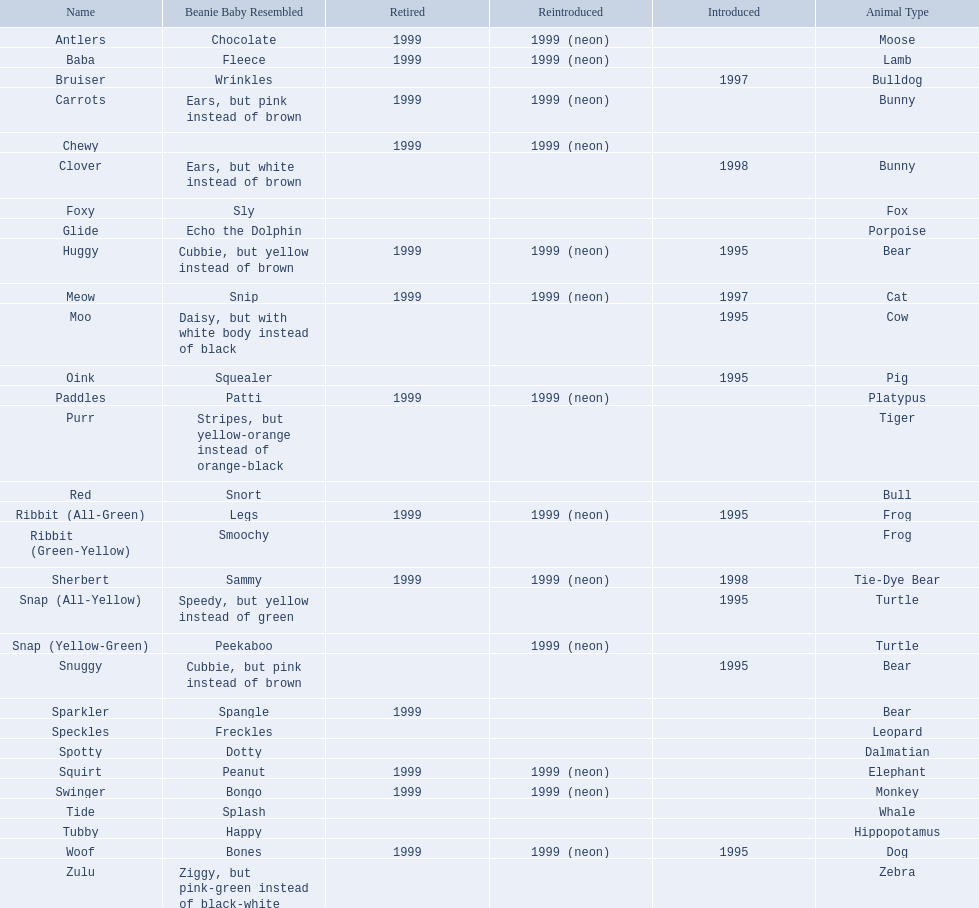What are all the different names of the pillow pals? Antlers, Baba, Bruiser, Carrots, Chewy, Clover, Foxy, Glide, Huggy, Meow, Moo, Oink, Paddles, Purr, Red, Ribbit (All-Green), Ribbit (Green-Yellow), Sherbert, Snap (All-Yellow), Snap (Yellow-Green), Snuggy, Sparkler, Speckles, Spotty, Squirt, Swinger, Tide, Tubby, Woof, Zulu. Which of these are a dalmatian? Spotty. Can you give me this table as a dict? {'header': ['Name', 'Beanie Baby Resembled', 'Retired', 'Reintroduced', 'Introduced', 'Animal Type'], 'rows': [['Antlers', 'Chocolate', '1999', '1999 (neon)', '', 'Moose'], ['Baba', 'Fleece', '1999', '1999 (neon)', '', 'Lamb'], ['Bruiser', 'Wrinkles', '', '', '1997', 'Bulldog'], ['Carrots', 'Ears, but pink instead of brown', '1999', '1999 (neon)', '', 'Bunny'], ['Chewy', '', '1999', '1999 (neon)', '', ''], ['Clover', 'Ears, but white instead of brown', '', '', '1998', 'Bunny'], ['Foxy', 'Sly', '', '', '', 'Fox'], ['Glide', 'Echo the Dolphin', '', '', '', 'Porpoise'], ['Huggy', 'Cubbie, but yellow instead of brown', '1999', '1999 (neon)', '1995', 'Bear'], ['Meow', 'Snip', '1999', '1999 (neon)', '1997', 'Cat'], ['Moo', 'Daisy, but with white body instead of black', '', '', '1995', 'Cow'], ['Oink', 'Squealer', '', '', '1995', 'Pig'], ['Paddles', 'Patti', '1999', '1999 (neon)', '', 'Platypus'], ['Purr', 'Stripes, but yellow-orange instead of orange-black', '', '', '', 'Tiger'], ['Red', 'Snort', '', '', '', 'Bull'], ['Ribbit (All-Green)', 'Legs', '1999', '1999 (neon)', '1995', 'Frog'], ['Ribbit (Green-Yellow)', 'Smoochy', '', '', '', 'Frog'], ['Sherbert', 'Sammy', '1999', '1999 (neon)', '1998', 'Tie-Dye Bear'], ['Snap (All-Yellow)', 'Speedy, but yellow instead of green', '', '', '1995', 'Turtle'], ['Snap (Yellow-Green)', 'Peekaboo', '', '1999 (neon)', '', 'Turtle'], ['Snuggy', 'Cubbie, but pink instead of brown', '', '', '1995', 'Bear'], ['Sparkler', 'Spangle', '1999', '', '', 'Bear'], ['Speckles', 'Freckles', '', '', '', 'Leopard'], ['Spotty', 'Dotty', '', '', '', 'Dalmatian'], ['Squirt', 'Peanut', '1999', '1999 (neon)', '', 'Elephant'], ['Swinger', 'Bongo', '1999', '1999 (neon)', '', 'Monkey'], ['Tide', 'Splash', '', '', '', 'Whale'], ['Tubby', 'Happy', '', '', '', 'Hippopotamus'], ['Woof', 'Bones', '1999', '1999 (neon)', '1995', 'Dog'], ['Zulu', 'Ziggy, but pink-green instead of black-white', '', '', '', 'Zebra']]} 